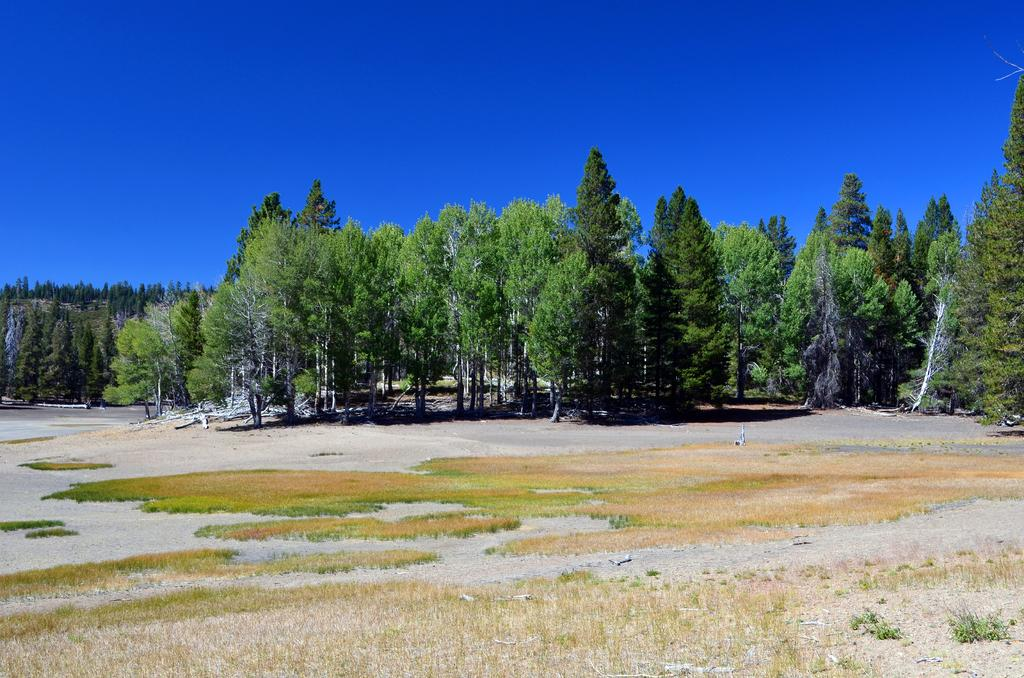What type of terrain is visible in the foreground of the image? There is grassland and trees in the foreground of the image. What can be seen in the background of the image? The sky is visible at the top of the image. What type of authority figure can be seen in the image? There is no authority figure present in the image; it features grassland, trees, and the sky. How many times are the trees being rubbed in the image? There is no rubbing of trees depicted in the image; it simply shows trees in the foreground. 